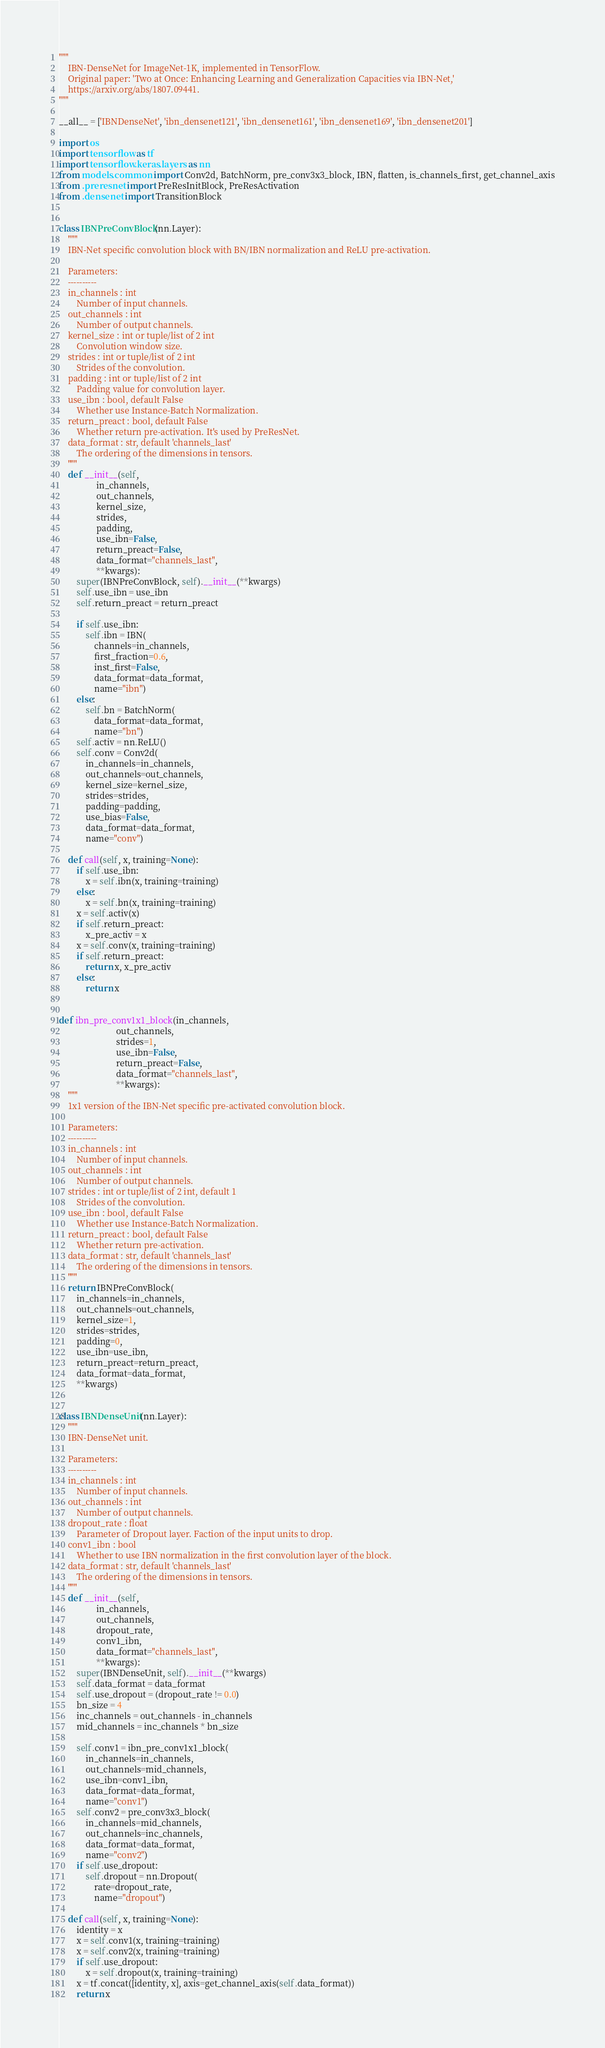<code> <loc_0><loc_0><loc_500><loc_500><_Python_>"""
    IBN-DenseNet for ImageNet-1K, implemented in TensorFlow.
    Original paper: 'Two at Once: Enhancing Learning and Generalization Capacities via IBN-Net,'
    https://arxiv.org/abs/1807.09441.
"""

__all__ = ['IBNDenseNet', 'ibn_densenet121', 'ibn_densenet161', 'ibn_densenet169', 'ibn_densenet201']

import os
import tensorflow as tf
import tensorflow.keras.layers as nn
from models.common import Conv2d, BatchNorm, pre_conv3x3_block, IBN, flatten, is_channels_first, get_channel_axis
from .preresnet import PreResInitBlock, PreResActivation
from .densenet import TransitionBlock


class IBNPreConvBlock(nn.Layer):
    """
    IBN-Net specific convolution block with BN/IBN normalization and ReLU pre-activation.

    Parameters:
    ----------
    in_channels : int
        Number of input channels.
    out_channels : int
        Number of output channels.
    kernel_size : int or tuple/list of 2 int
        Convolution window size.
    strides : int or tuple/list of 2 int
        Strides of the convolution.
    padding : int or tuple/list of 2 int
        Padding value for convolution layer.
    use_ibn : bool, default False
        Whether use Instance-Batch Normalization.
    return_preact : bool, default False
        Whether return pre-activation. It's used by PreResNet.
    data_format : str, default 'channels_last'
        The ordering of the dimensions in tensors.
    """
    def __init__(self,
                 in_channels,
                 out_channels,
                 kernel_size,
                 strides,
                 padding,
                 use_ibn=False,
                 return_preact=False,
                 data_format="channels_last",
                 **kwargs):
        super(IBNPreConvBlock, self).__init__(**kwargs)
        self.use_ibn = use_ibn
        self.return_preact = return_preact

        if self.use_ibn:
            self.ibn = IBN(
                channels=in_channels,
                first_fraction=0.6,
                inst_first=False,
                data_format=data_format,
                name="ibn")
        else:
            self.bn = BatchNorm(
                data_format=data_format,
                name="bn")
        self.activ = nn.ReLU()
        self.conv = Conv2d(
            in_channels=in_channels,
            out_channels=out_channels,
            kernel_size=kernel_size,
            strides=strides,
            padding=padding,
            use_bias=False,
            data_format=data_format,
            name="conv")

    def call(self, x, training=None):
        if self.use_ibn:
            x = self.ibn(x, training=training)
        else:
            x = self.bn(x, training=training)
        x = self.activ(x)
        if self.return_preact:
            x_pre_activ = x
        x = self.conv(x, training=training)
        if self.return_preact:
            return x, x_pre_activ
        else:
            return x


def ibn_pre_conv1x1_block(in_channels,
                          out_channels,
                          strides=1,
                          use_ibn=False,
                          return_preact=False,
                          data_format="channels_last",
                          **kwargs):
    """
    1x1 version of the IBN-Net specific pre-activated convolution block.

    Parameters:
    ----------
    in_channels : int
        Number of input channels.
    out_channels : int
        Number of output channels.
    strides : int or tuple/list of 2 int, default 1
        Strides of the convolution.
    use_ibn : bool, default False
        Whether use Instance-Batch Normalization.
    return_preact : bool, default False
        Whether return pre-activation.
    data_format : str, default 'channels_last'
        The ordering of the dimensions in tensors.
    """
    return IBNPreConvBlock(
        in_channels=in_channels,
        out_channels=out_channels,
        kernel_size=1,
        strides=strides,
        padding=0,
        use_ibn=use_ibn,
        return_preact=return_preact,
        data_format=data_format,
        **kwargs)


class IBNDenseUnit(nn.Layer):
    """
    IBN-DenseNet unit.

    Parameters:
    ----------
    in_channels : int
        Number of input channels.
    out_channels : int
        Number of output channels.
    dropout_rate : float
        Parameter of Dropout layer. Faction of the input units to drop.
    conv1_ibn : bool
        Whether to use IBN normalization in the first convolution layer of the block.
    data_format : str, default 'channels_last'
        The ordering of the dimensions in tensors.
    """
    def __init__(self,
                 in_channels,
                 out_channels,
                 dropout_rate,
                 conv1_ibn,
                 data_format="channels_last",
                 **kwargs):
        super(IBNDenseUnit, self).__init__(**kwargs)
        self.data_format = data_format
        self.use_dropout = (dropout_rate != 0.0)
        bn_size = 4
        inc_channels = out_channels - in_channels
        mid_channels = inc_channels * bn_size

        self.conv1 = ibn_pre_conv1x1_block(
            in_channels=in_channels,
            out_channels=mid_channels,
            use_ibn=conv1_ibn,
            data_format=data_format,
            name="conv1")
        self.conv2 = pre_conv3x3_block(
            in_channels=mid_channels,
            out_channels=inc_channels,
            data_format=data_format,
            name="conv2")
        if self.use_dropout:
            self.dropout = nn.Dropout(
                rate=dropout_rate,
                name="dropout")

    def call(self, x, training=None):
        identity = x
        x = self.conv1(x, training=training)
        x = self.conv2(x, training=training)
        if self.use_dropout:
            x = self.dropout(x, training=training)
        x = tf.concat([identity, x], axis=get_channel_axis(self.data_format))
        return x

</code> 